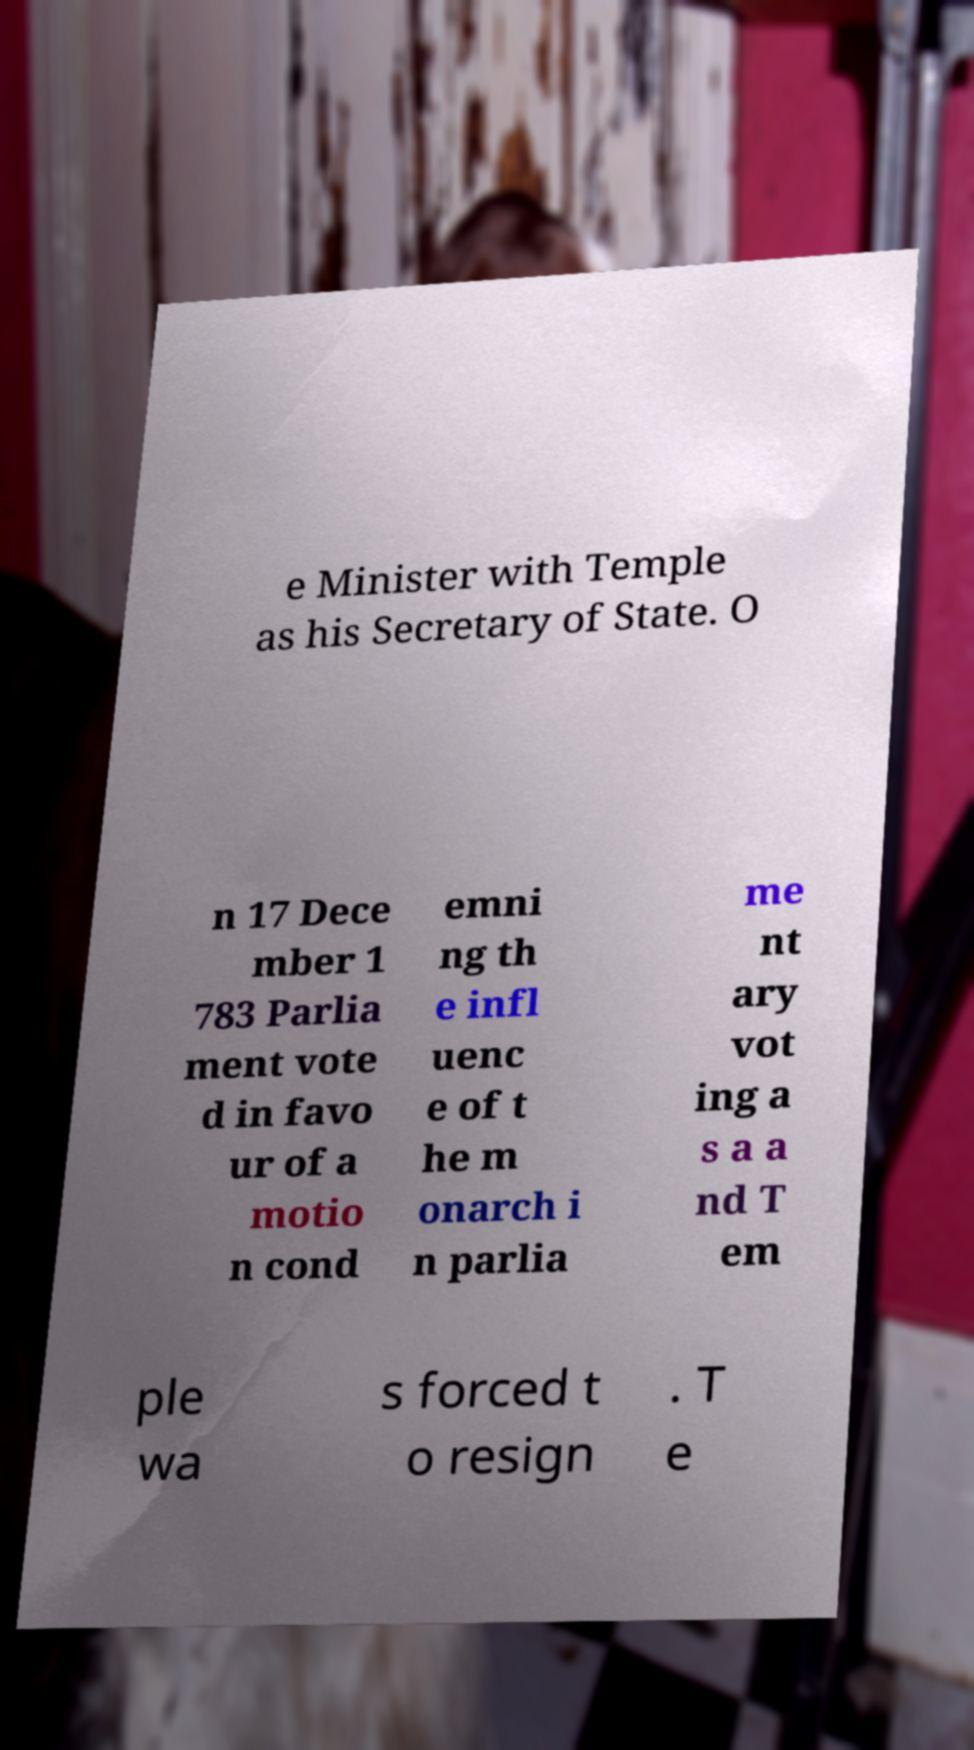Could you extract and type out the text from this image? e Minister with Temple as his Secretary of State. O n 17 Dece mber 1 783 Parlia ment vote d in favo ur of a motio n cond emni ng th e infl uenc e of t he m onarch i n parlia me nt ary vot ing a s a a nd T em ple wa s forced t o resign . T e 